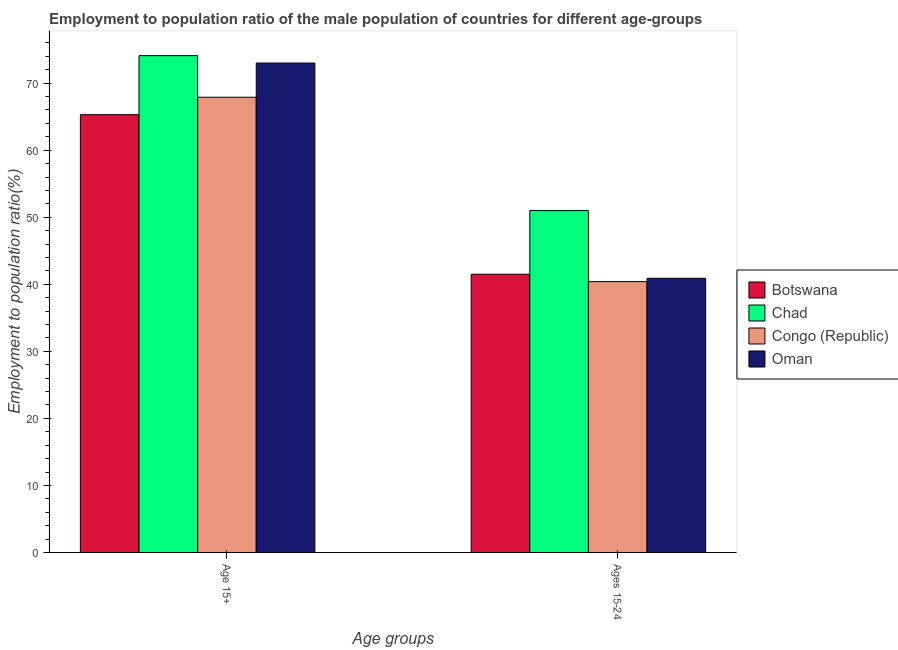How many different coloured bars are there?
Keep it short and to the point. 4. Are the number of bars per tick equal to the number of legend labels?
Make the answer very short. Yes. What is the label of the 2nd group of bars from the left?
Keep it short and to the point. Ages 15-24. What is the employment to population ratio(age 15+) in Chad?
Keep it short and to the point. 74.1. Across all countries, what is the maximum employment to population ratio(age 15+)?
Offer a terse response. 74.1. Across all countries, what is the minimum employment to population ratio(age 15+)?
Your answer should be very brief. 65.3. In which country was the employment to population ratio(age 15+) maximum?
Offer a very short reply. Chad. In which country was the employment to population ratio(age 15-24) minimum?
Your answer should be compact. Congo (Republic). What is the total employment to population ratio(age 15+) in the graph?
Provide a short and direct response. 280.3. What is the difference between the employment to population ratio(age 15+) in Congo (Republic) and that in Oman?
Make the answer very short. -5.1. What is the difference between the employment to population ratio(age 15-24) in Congo (Republic) and the employment to population ratio(age 15+) in Oman?
Give a very brief answer. -32.6. What is the average employment to population ratio(age 15-24) per country?
Your answer should be compact. 43.45. What is the difference between the employment to population ratio(age 15-24) and employment to population ratio(age 15+) in Oman?
Offer a terse response. -32.1. In how many countries, is the employment to population ratio(age 15+) greater than 42 %?
Your response must be concise. 4. What is the ratio of the employment to population ratio(age 15-24) in Botswana to that in Congo (Republic)?
Provide a succinct answer. 1.03. Is the employment to population ratio(age 15-24) in Oman less than that in Chad?
Make the answer very short. Yes. What does the 2nd bar from the left in Ages 15-24 represents?
Make the answer very short. Chad. What does the 1st bar from the right in Ages 15-24 represents?
Your answer should be very brief. Oman. How many bars are there?
Give a very brief answer. 8. Are all the bars in the graph horizontal?
Offer a very short reply. No. What is the difference between two consecutive major ticks on the Y-axis?
Ensure brevity in your answer.  10. Are the values on the major ticks of Y-axis written in scientific E-notation?
Offer a terse response. No. Does the graph contain grids?
Provide a short and direct response. No. What is the title of the graph?
Give a very brief answer. Employment to population ratio of the male population of countries for different age-groups. What is the label or title of the X-axis?
Make the answer very short. Age groups. What is the Employment to population ratio(%) in Botswana in Age 15+?
Provide a short and direct response. 65.3. What is the Employment to population ratio(%) in Chad in Age 15+?
Ensure brevity in your answer.  74.1. What is the Employment to population ratio(%) in Congo (Republic) in Age 15+?
Offer a terse response. 67.9. What is the Employment to population ratio(%) of Botswana in Ages 15-24?
Give a very brief answer. 41.5. What is the Employment to population ratio(%) in Congo (Republic) in Ages 15-24?
Your answer should be very brief. 40.4. What is the Employment to population ratio(%) of Oman in Ages 15-24?
Offer a terse response. 40.9. Across all Age groups, what is the maximum Employment to population ratio(%) of Botswana?
Offer a very short reply. 65.3. Across all Age groups, what is the maximum Employment to population ratio(%) of Chad?
Your answer should be compact. 74.1. Across all Age groups, what is the maximum Employment to population ratio(%) of Congo (Republic)?
Ensure brevity in your answer.  67.9. Across all Age groups, what is the maximum Employment to population ratio(%) in Oman?
Provide a succinct answer. 73. Across all Age groups, what is the minimum Employment to population ratio(%) in Botswana?
Offer a terse response. 41.5. Across all Age groups, what is the minimum Employment to population ratio(%) in Congo (Republic)?
Ensure brevity in your answer.  40.4. Across all Age groups, what is the minimum Employment to population ratio(%) of Oman?
Provide a short and direct response. 40.9. What is the total Employment to population ratio(%) in Botswana in the graph?
Offer a very short reply. 106.8. What is the total Employment to population ratio(%) of Chad in the graph?
Your response must be concise. 125.1. What is the total Employment to population ratio(%) of Congo (Republic) in the graph?
Provide a succinct answer. 108.3. What is the total Employment to population ratio(%) in Oman in the graph?
Your response must be concise. 113.9. What is the difference between the Employment to population ratio(%) of Botswana in Age 15+ and that in Ages 15-24?
Offer a very short reply. 23.8. What is the difference between the Employment to population ratio(%) in Chad in Age 15+ and that in Ages 15-24?
Offer a very short reply. 23.1. What is the difference between the Employment to population ratio(%) of Oman in Age 15+ and that in Ages 15-24?
Give a very brief answer. 32.1. What is the difference between the Employment to population ratio(%) in Botswana in Age 15+ and the Employment to population ratio(%) in Congo (Republic) in Ages 15-24?
Offer a very short reply. 24.9. What is the difference between the Employment to population ratio(%) of Botswana in Age 15+ and the Employment to population ratio(%) of Oman in Ages 15-24?
Make the answer very short. 24.4. What is the difference between the Employment to population ratio(%) of Chad in Age 15+ and the Employment to population ratio(%) of Congo (Republic) in Ages 15-24?
Give a very brief answer. 33.7. What is the difference between the Employment to population ratio(%) in Chad in Age 15+ and the Employment to population ratio(%) in Oman in Ages 15-24?
Provide a succinct answer. 33.2. What is the difference between the Employment to population ratio(%) in Congo (Republic) in Age 15+ and the Employment to population ratio(%) in Oman in Ages 15-24?
Offer a very short reply. 27. What is the average Employment to population ratio(%) of Botswana per Age groups?
Your answer should be compact. 53.4. What is the average Employment to population ratio(%) in Chad per Age groups?
Offer a terse response. 62.55. What is the average Employment to population ratio(%) in Congo (Republic) per Age groups?
Offer a very short reply. 54.15. What is the average Employment to population ratio(%) in Oman per Age groups?
Make the answer very short. 56.95. What is the difference between the Employment to population ratio(%) of Botswana and Employment to population ratio(%) of Oman in Age 15+?
Offer a terse response. -7.7. What is the difference between the Employment to population ratio(%) of Chad and Employment to population ratio(%) of Congo (Republic) in Age 15+?
Give a very brief answer. 6.2. What is the difference between the Employment to population ratio(%) of Chad and Employment to population ratio(%) of Oman in Age 15+?
Keep it short and to the point. 1.1. What is the difference between the Employment to population ratio(%) in Botswana and Employment to population ratio(%) in Chad in Ages 15-24?
Give a very brief answer. -9.5. What is the difference between the Employment to population ratio(%) in Botswana and Employment to population ratio(%) in Congo (Republic) in Ages 15-24?
Offer a terse response. 1.1. What is the difference between the Employment to population ratio(%) of Botswana and Employment to population ratio(%) of Oman in Ages 15-24?
Offer a terse response. 0.6. What is the difference between the Employment to population ratio(%) in Chad and Employment to population ratio(%) in Congo (Republic) in Ages 15-24?
Make the answer very short. 10.6. What is the difference between the Employment to population ratio(%) of Chad and Employment to population ratio(%) of Oman in Ages 15-24?
Provide a succinct answer. 10.1. What is the ratio of the Employment to population ratio(%) in Botswana in Age 15+ to that in Ages 15-24?
Make the answer very short. 1.57. What is the ratio of the Employment to population ratio(%) in Chad in Age 15+ to that in Ages 15-24?
Ensure brevity in your answer.  1.45. What is the ratio of the Employment to population ratio(%) in Congo (Republic) in Age 15+ to that in Ages 15-24?
Your response must be concise. 1.68. What is the ratio of the Employment to population ratio(%) of Oman in Age 15+ to that in Ages 15-24?
Offer a very short reply. 1.78. What is the difference between the highest and the second highest Employment to population ratio(%) of Botswana?
Keep it short and to the point. 23.8. What is the difference between the highest and the second highest Employment to population ratio(%) of Chad?
Your answer should be compact. 23.1. What is the difference between the highest and the second highest Employment to population ratio(%) of Congo (Republic)?
Give a very brief answer. 27.5. What is the difference between the highest and the second highest Employment to population ratio(%) in Oman?
Offer a terse response. 32.1. What is the difference between the highest and the lowest Employment to population ratio(%) in Botswana?
Make the answer very short. 23.8. What is the difference between the highest and the lowest Employment to population ratio(%) in Chad?
Offer a very short reply. 23.1. What is the difference between the highest and the lowest Employment to population ratio(%) of Congo (Republic)?
Keep it short and to the point. 27.5. What is the difference between the highest and the lowest Employment to population ratio(%) in Oman?
Keep it short and to the point. 32.1. 